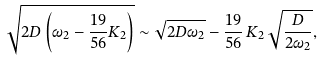Convert formula to latex. <formula><loc_0><loc_0><loc_500><loc_500>\sqrt { 2 D \left ( \omega _ { 2 } - \frac { 1 9 } { 5 6 } K _ { 2 } \right ) } \sim \sqrt { 2 D \omega _ { 2 } } - \frac { 1 9 } { 5 6 } \, K _ { 2 } \, \sqrt { \frac { D } { 2 \omega _ { 2 } } } ,</formula> 